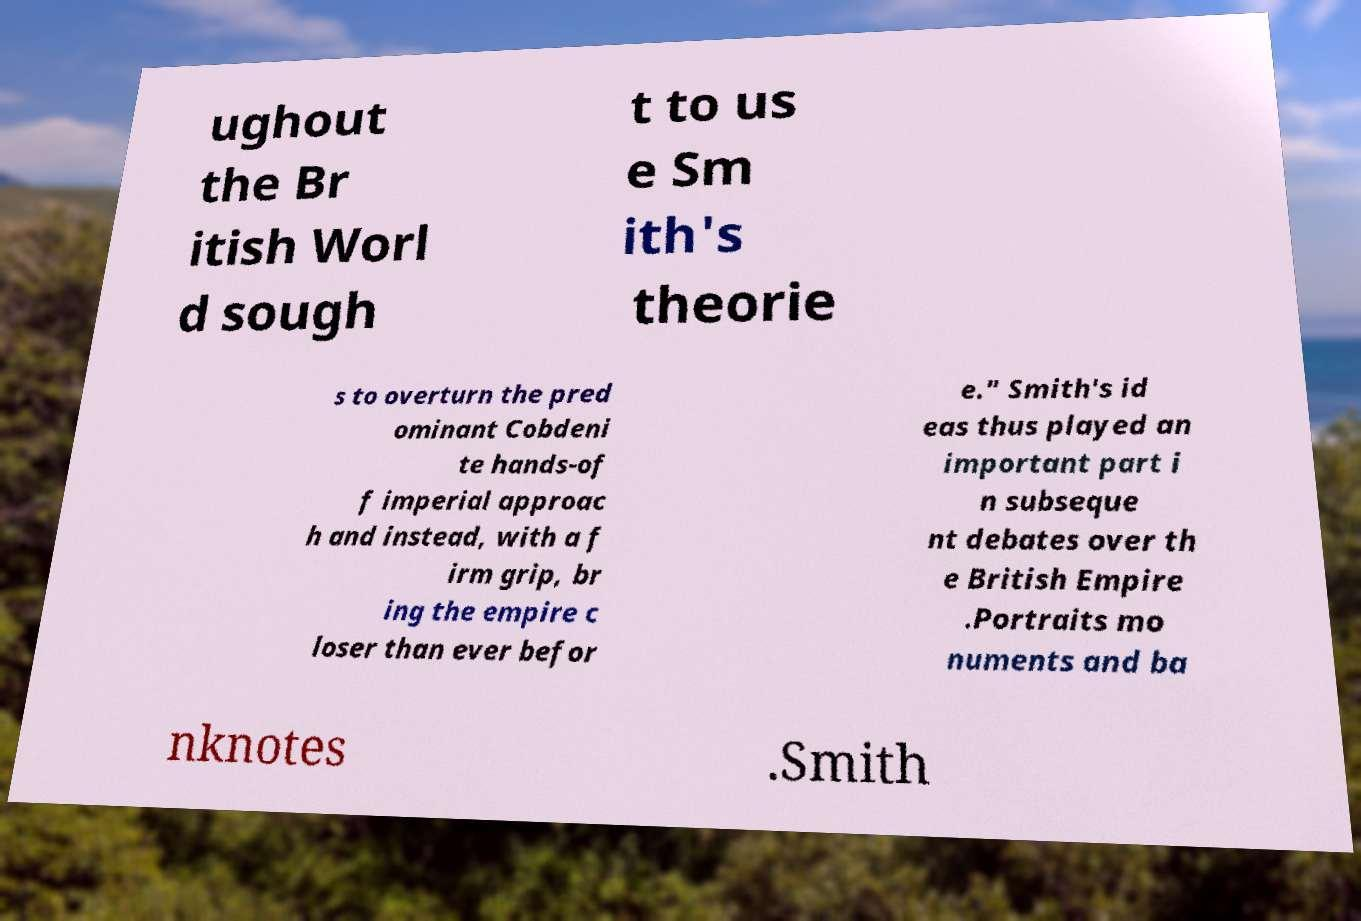Can you read and provide the text displayed in the image?This photo seems to have some interesting text. Can you extract and type it out for me? ughout the Br itish Worl d sough t to us e Sm ith's theorie s to overturn the pred ominant Cobdeni te hands-of f imperial approac h and instead, with a f irm grip, br ing the empire c loser than ever befor e." Smith's id eas thus played an important part i n subseque nt debates over th e British Empire .Portraits mo numents and ba nknotes .Smith 